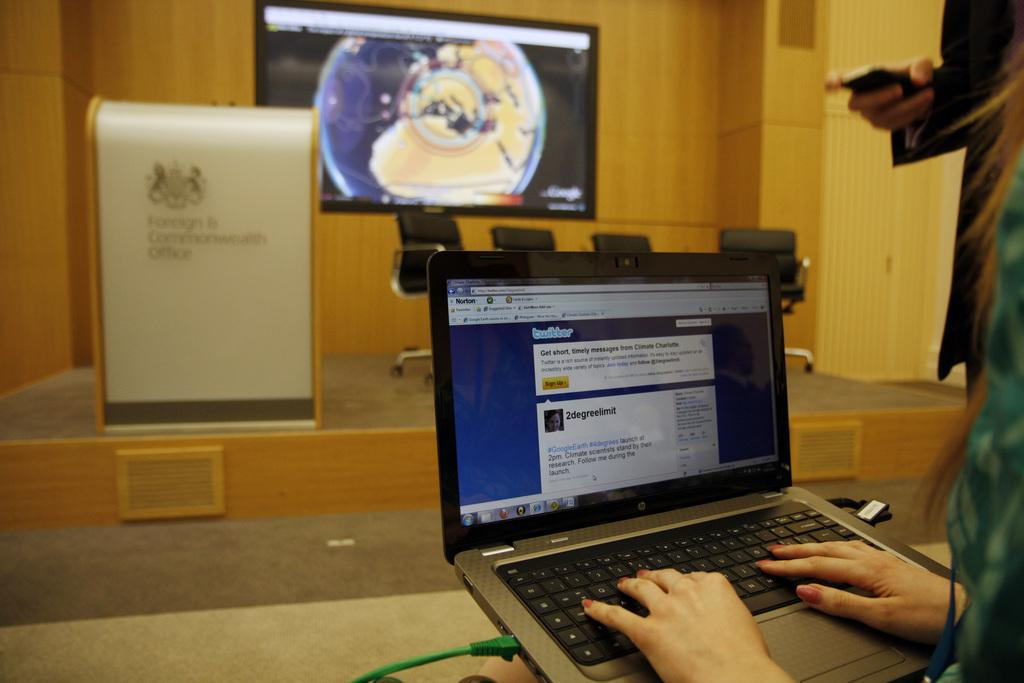<image>
Describe the image concisely. The person shown is on a computer on the twitter app. 